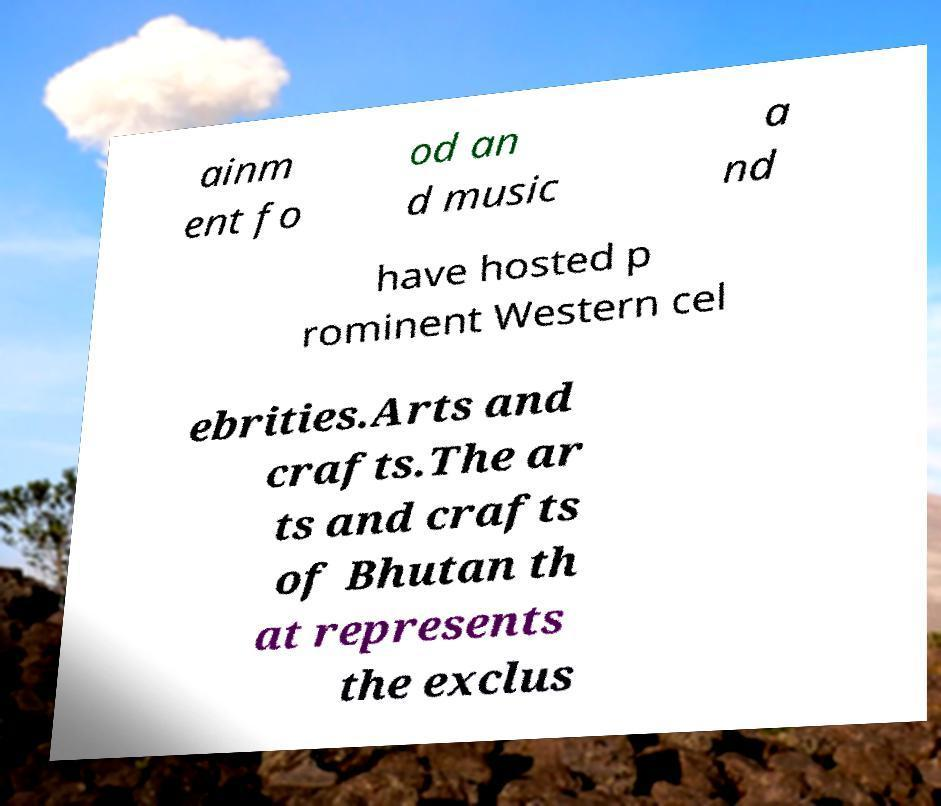Please read and relay the text visible in this image. What does it say? ainm ent fo od an d music a nd have hosted p rominent Western cel ebrities.Arts and crafts.The ar ts and crafts of Bhutan th at represents the exclus 